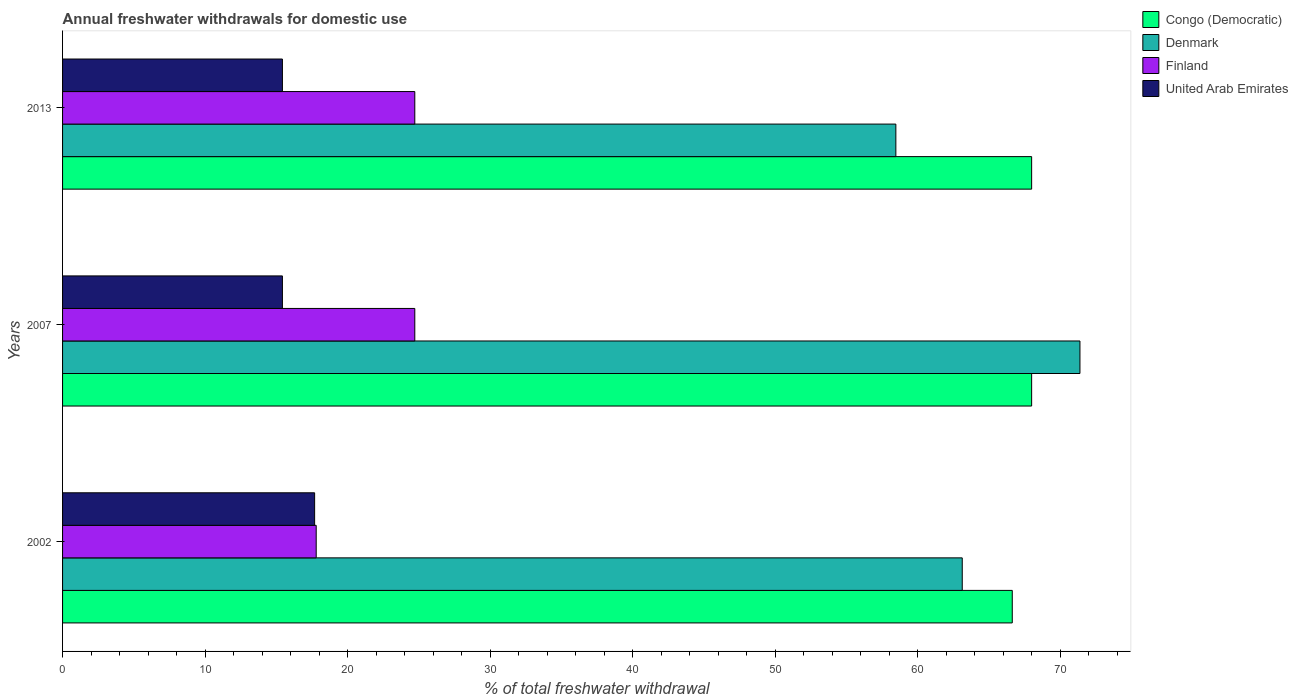How many groups of bars are there?
Provide a succinct answer. 3. Are the number of bars per tick equal to the number of legend labels?
Keep it short and to the point. Yes. Are the number of bars on each tick of the Y-axis equal?
Give a very brief answer. Yes. How many bars are there on the 2nd tick from the top?
Make the answer very short. 4. How many bars are there on the 1st tick from the bottom?
Offer a terse response. 4. In how many cases, is the number of bars for a given year not equal to the number of legend labels?
Give a very brief answer. 0. Across all years, what is the maximum total annual withdrawals from freshwater in United Arab Emirates?
Provide a succinct answer. 17.69. Across all years, what is the minimum total annual withdrawals from freshwater in Congo (Democratic)?
Your answer should be compact. 66.65. In which year was the total annual withdrawals from freshwater in Congo (Democratic) minimum?
Your answer should be very brief. 2002. What is the total total annual withdrawals from freshwater in Denmark in the graph?
Keep it short and to the point. 193.02. What is the difference between the total annual withdrawals from freshwater in United Arab Emirates in 2002 and that in 2013?
Your response must be concise. 2.26. What is the difference between the total annual withdrawals from freshwater in Congo (Democratic) in 2007 and the total annual withdrawals from freshwater in United Arab Emirates in 2002?
Keep it short and to the point. 50.32. What is the average total annual withdrawals from freshwater in Finland per year?
Your answer should be compact. 22.41. In the year 2007, what is the difference between the total annual withdrawals from freshwater in Congo (Democratic) and total annual withdrawals from freshwater in Finland?
Keep it short and to the point. 43.29. In how many years, is the total annual withdrawals from freshwater in Finland greater than 58 %?
Make the answer very short. 0. What is the ratio of the total annual withdrawals from freshwater in Finland in 2002 to that in 2013?
Your answer should be very brief. 0.72. Is the total annual withdrawals from freshwater in United Arab Emirates in 2002 less than that in 2007?
Offer a very short reply. No. Is the difference between the total annual withdrawals from freshwater in Congo (Democratic) in 2002 and 2007 greater than the difference between the total annual withdrawals from freshwater in Finland in 2002 and 2007?
Offer a terse response. Yes. What is the difference between the highest and the second highest total annual withdrawals from freshwater in United Arab Emirates?
Make the answer very short. 2.26. What is the difference between the highest and the lowest total annual withdrawals from freshwater in Denmark?
Make the answer very short. 12.92. In how many years, is the total annual withdrawals from freshwater in Finland greater than the average total annual withdrawals from freshwater in Finland taken over all years?
Keep it short and to the point. 2. What does the 3rd bar from the top in 2013 represents?
Make the answer very short. Denmark. What does the 1st bar from the bottom in 2013 represents?
Keep it short and to the point. Congo (Democratic). Is it the case that in every year, the sum of the total annual withdrawals from freshwater in United Arab Emirates and total annual withdrawals from freshwater in Congo (Democratic) is greater than the total annual withdrawals from freshwater in Finland?
Give a very brief answer. Yes. How many bars are there?
Your answer should be very brief. 12. Are all the bars in the graph horizontal?
Provide a succinct answer. Yes. How many years are there in the graph?
Offer a terse response. 3. Does the graph contain any zero values?
Give a very brief answer. No. Does the graph contain grids?
Ensure brevity in your answer.  No. What is the title of the graph?
Provide a short and direct response. Annual freshwater withdrawals for domestic use. Does "Nigeria" appear as one of the legend labels in the graph?
Offer a very short reply. No. What is the label or title of the X-axis?
Keep it short and to the point. % of total freshwater withdrawal. What is the % of total freshwater withdrawal in Congo (Democratic) in 2002?
Keep it short and to the point. 66.65. What is the % of total freshwater withdrawal of Denmark in 2002?
Your response must be concise. 63.14. What is the % of total freshwater withdrawal of Finland in 2002?
Give a very brief answer. 17.8. What is the % of total freshwater withdrawal in United Arab Emirates in 2002?
Give a very brief answer. 17.69. What is the % of total freshwater withdrawal of Congo (Democratic) in 2007?
Your answer should be compact. 68.01. What is the % of total freshwater withdrawal of Denmark in 2007?
Your answer should be very brief. 71.4. What is the % of total freshwater withdrawal in Finland in 2007?
Keep it short and to the point. 24.72. What is the % of total freshwater withdrawal in United Arab Emirates in 2007?
Provide a short and direct response. 15.43. What is the % of total freshwater withdrawal in Congo (Democratic) in 2013?
Provide a short and direct response. 68.01. What is the % of total freshwater withdrawal of Denmark in 2013?
Your response must be concise. 58.48. What is the % of total freshwater withdrawal in Finland in 2013?
Your answer should be compact. 24.72. What is the % of total freshwater withdrawal in United Arab Emirates in 2013?
Give a very brief answer. 15.43. Across all years, what is the maximum % of total freshwater withdrawal in Congo (Democratic)?
Offer a terse response. 68.01. Across all years, what is the maximum % of total freshwater withdrawal in Denmark?
Your answer should be very brief. 71.4. Across all years, what is the maximum % of total freshwater withdrawal in Finland?
Keep it short and to the point. 24.72. Across all years, what is the maximum % of total freshwater withdrawal of United Arab Emirates?
Make the answer very short. 17.69. Across all years, what is the minimum % of total freshwater withdrawal in Congo (Democratic)?
Provide a succinct answer. 66.65. Across all years, what is the minimum % of total freshwater withdrawal of Denmark?
Make the answer very short. 58.48. Across all years, what is the minimum % of total freshwater withdrawal in United Arab Emirates?
Offer a terse response. 15.43. What is the total % of total freshwater withdrawal of Congo (Democratic) in the graph?
Keep it short and to the point. 202.67. What is the total % of total freshwater withdrawal of Denmark in the graph?
Your answer should be very brief. 193.02. What is the total % of total freshwater withdrawal in Finland in the graph?
Your answer should be compact. 67.24. What is the total % of total freshwater withdrawal of United Arab Emirates in the graph?
Your response must be concise. 48.55. What is the difference between the % of total freshwater withdrawal in Congo (Democratic) in 2002 and that in 2007?
Offer a very short reply. -1.36. What is the difference between the % of total freshwater withdrawal in Denmark in 2002 and that in 2007?
Your response must be concise. -8.26. What is the difference between the % of total freshwater withdrawal in Finland in 2002 and that in 2007?
Provide a succinct answer. -6.92. What is the difference between the % of total freshwater withdrawal of United Arab Emirates in 2002 and that in 2007?
Ensure brevity in your answer.  2.26. What is the difference between the % of total freshwater withdrawal in Congo (Democratic) in 2002 and that in 2013?
Give a very brief answer. -1.36. What is the difference between the % of total freshwater withdrawal of Denmark in 2002 and that in 2013?
Offer a very short reply. 4.66. What is the difference between the % of total freshwater withdrawal of Finland in 2002 and that in 2013?
Your answer should be very brief. -6.92. What is the difference between the % of total freshwater withdrawal in United Arab Emirates in 2002 and that in 2013?
Your answer should be very brief. 2.26. What is the difference between the % of total freshwater withdrawal of Denmark in 2007 and that in 2013?
Ensure brevity in your answer.  12.92. What is the difference between the % of total freshwater withdrawal of Finland in 2007 and that in 2013?
Provide a short and direct response. 0. What is the difference between the % of total freshwater withdrawal in United Arab Emirates in 2007 and that in 2013?
Provide a succinct answer. 0. What is the difference between the % of total freshwater withdrawal of Congo (Democratic) in 2002 and the % of total freshwater withdrawal of Denmark in 2007?
Offer a terse response. -4.75. What is the difference between the % of total freshwater withdrawal of Congo (Democratic) in 2002 and the % of total freshwater withdrawal of Finland in 2007?
Provide a short and direct response. 41.93. What is the difference between the % of total freshwater withdrawal of Congo (Democratic) in 2002 and the % of total freshwater withdrawal of United Arab Emirates in 2007?
Keep it short and to the point. 51.22. What is the difference between the % of total freshwater withdrawal of Denmark in 2002 and the % of total freshwater withdrawal of Finland in 2007?
Make the answer very short. 38.42. What is the difference between the % of total freshwater withdrawal in Denmark in 2002 and the % of total freshwater withdrawal in United Arab Emirates in 2007?
Give a very brief answer. 47.71. What is the difference between the % of total freshwater withdrawal of Finland in 2002 and the % of total freshwater withdrawal of United Arab Emirates in 2007?
Your answer should be compact. 2.37. What is the difference between the % of total freshwater withdrawal of Congo (Democratic) in 2002 and the % of total freshwater withdrawal of Denmark in 2013?
Your answer should be compact. 8.17. What is the difference between the % of total freshwater withdrawal of Congo (Democratic) in 2002 and the % of total freshwater withdrawal of Finland in 2013?
Offer a terse response. 41.93. What is the difference between the % of total freshwater withdrawal in Congo (Democratic) in 2002 and the % of total freshwater withdrawal in United Arab Emirates in 2013?
Provide a succinct answer. 51.22. What is the difference between the % of total freshwater withdrawal of Denmark in 2002 and the % of total freshwater withdrawal of Finland in 2013?
Offer a terse response. 38.42. What is the difference between the % of total freshwater withdrawal in Denmark in 2002 and the % of total freshwater withdrawal in United Arab Emirates in 2013?
Offer a terse response. 47.71. What is the difference between the % of total freshwater withdrawal in Finland in 2002 and the % of total freshwater withdrawal in United Arab Emirates in 2013?
Provide a succinct answer. 2.37. What is the difference between the % of total freshwater withdrawal of Congo (Democratic) in 2007 and the % of total freshwater withdrawal of Denmark in 2013?
Your response must be concise. 9.53. What is the difference between the % of total freshwater withdrawal of Congo (Democratic) in 2007 and the % of total freshwater withdrawal of Finland in 2013?
Provide a short and direct response. 43.29. What is the difference between the % of total freshwater withdrawal of Congo (Democratic) in 2007 and the % of total freshwater withdrawal of United Arab Emirates in 2013?
Your response must be concise. 52.58. What is the difference between the % of total freshwater withdrawal in Denmark in 2007 and the % of total freshwater withdrawal in Finland in 2013?
Make the answer very short. 46.68. What is the difference between the % of total freshwater withdrawal of Denmark in 2007 and the % of total freshwater withdrawal of United Arab Emirates in 2013?
Offer a terse response. 55.97. What is the difference between the % of total freshwater withdrawal of Finland in 2007 and the % of total freshwater withdrawal of United Arab Emirates in 2013?
Provide a succinct answer. 9.29. What is the average % of total freshwater withdrawal of Congo (Democratic) per year?
Keep it short and to the point. 67.56. What is the average % of total freshwater withdrawal of Denmark per year?
Make the answer very short. 64.34. What is the average % of total freshwater withdrawal of Finland per year?
Provide a succinct answer. 22.41. What is the average % of total freshwater withdrawal in United Arab Emirates per year?
Give a very brief answer. 16.18. In the year 2002, what is the difference between the % of total freshwater withdrawal in Congo (Democratic) and % of total freshwater withdrawal in Denmark?
Offer a terse response. 3.51. In the year 2002, what is the difference between the % of total freshwater withdrawal of Congo (Democratic) and % of total freshwater withdrawal of Finland?
Make the answer very short. 48.85. In the year 2002, what is the difference between the % of total freshwater withdrawal in Congo (Democratic) and % of total freshwater withdrawal in United Arab Emirates?
Provide a succinct answer. 48.96. In the year 2002, what is the difference between the % of total freshwater withdrawal of Denmark and % of total freshwater withdrawal of Finland?
Provide a short and direct response. 45.34. In the year 2002, what is the difference between the % of total freshwater withdrawal of Denmark and % of total freshwater withdrawal of United Arab Emirates?
Give a very brief answer. 45.45. In the year 2002, what is the difference between the % of total freshwater withdrawal of Finland and % of total freshwater withdrawal of United Arab Emirates?
Provide a succinct answer. 0.11. In the year 2007, what is the difference between the % of total freshwater withdrawal of Congo (Democratic) and % of total freshwater withdrawal of Denmark?
Keep it short and to the point. -3.39. In the year 2007, what is the difference between the % of total freshwater withdrawal of Congo (Democratic) and % of total freshwater withdrawal of Finland?
Your answer should be compact. 43.29. In the year 2007, what is the difference between the % of total freshwater withdrawal of Congo (Democratic) and % of total freshwater withdrawal of United Arab Emirates?
Your answer should be compact. 52.58. In the year 2007, what is the difference between the % of total freshwater withdrawal in Denmark and % of total freshwater withdrawal in Finland?
Provide a succinct answer. 46.68. In the year 2007, what is the difference between the % of total freshwater withdrawal in Denmark and % of total freshwater withdrawal in United Arab Emirates?
Give a very brief answer. 55.97. In the year 2007, what is the difference between the % of total freshwater withdrawal of Finland and % of total freshwater withdrawal of United Arab Emirates?
Offer a terse response. 9.29. In the year 2013, what is the difference between the % of total freshwater withdrawal in Congo (Democratic) and % of total freshwater withdrawal in Denmark?
Your answer should be very brief. 9.53. In the year 2013, what is the difference between the % of total freshwater withdrawal in Congo (Democratic) and % of total freshwater withdrawal in Finland?
Keep it short and to the point. 43.29. In the year 2013, what is the difference between the % of total freshwater withdrawal in Congo (Democratic) and % of total freshwater withdrawal in United Arab Emirates?
Keep it short and to the point. 52.58. In the year 2013, what is the difference between the % of total freshwater withdrawal of Denmark and % of total freshwater withdrawal of Finland?
Offer a very short reply. 33.76. In the year 2013, what is the difference between the % of total freshwater withdrawal in Denmark and % of total freshwater withdrawal in United Arab Emirates?
Your response must be concise. 43.05. In the year 2013, what is the difference between the % of total freshwater withdrawal in Finland and % of total freshwater withdrawal in United Arab Emirates?
Keep it short and to the point. 9.29. What is the ratio of the % of total freshwater withdrawal in Congo (Democratic) in 2002 to that in 2007?
Your answer should be very brief. 0.98. What is the ratio of the % of total freshwater withdrawal of Denmark in 2002 to that in 2007?
Ensure brevity in your answer.  0.88. What is the ratio of the % of total freshwater withdrawal of Finland in 2002 to that in 2007?
Make the answer very short. 0.72. What is the ratio of the % of total freshwater withdrawal in United Arab Emirates in 2002 to that in 2007?
Keep it short and to the point. 1.15. What is the ratio of the % of total freshwater withdrawal in Congo (Democratic) in 2002 to that in 2013?
Provide a succinct answer. 0.98. What is the ratio of the % of total freshwater withdrawal of Denmark in 2002 to that in 2013?
Offer a terse response. 1.08. What is the ratio of the % of total freshwater withdrawal of Finland in 2002 to that in 2013?
Give a very brief answer. 0.72. What is the ratio of the % of total freshwater withdrawal in United Arab Emirates in 2002 to that in 2013?
Offer a terse response. 1.15. What is the ratio of the % of total freshwater withdrawal in Congo (Democratic) in 2007 to that in 2013?
Provide a short and direct response. 1. What is the ratio of the % of total freshwater withdrawal in Denmark in 2007 to that in 2013?
Give a very brief answer. 1.22. What is the ratio of the % of total freshwater withdrawal of United Arab Emirates in 2007 to that in 2013?
Provide a short and direct response. 1. What is the difference between the highest and the second highest % of total freshwater withdrawal of Denmark?
Give a very brief answer. 8.26. What is the difference between the highest and the second highest % of total freshwater withdrawal of United Arab Emirates?
Your response must be concise. 2.26. What is the difference between the highest and the lowest % of total freshwater withdrawal in Congo (Democratic)?
Your answer should be very brief. 1.36. What is the difference between the highest and the lowest % of total freshwater withdrawal in Denmark?
Ensure brevity in your answer.  12.92. What is the difference between the highest and the lowest % of total freshwater withdrawal of Finland?
Your response must be concise. 6.92. What is the difference between the highest and the lowest % of total freshwater withdrawal of United Arab Emirates?
Make the answer very short. 2.26. 